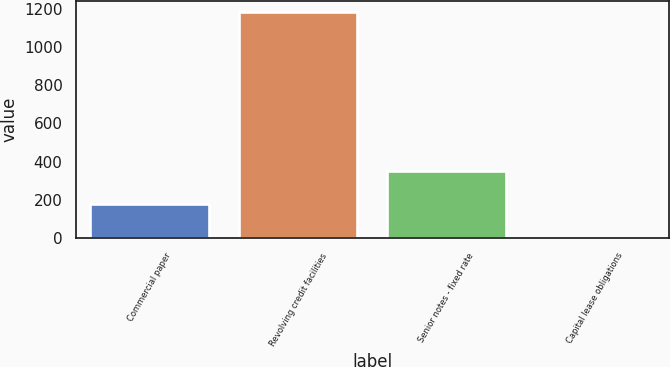<chart> <loc_0><loc_0><loc_500><loc_500><bar_chart><fcel>Commercial paper<fcel>Revolving credit facilities<fcel>Senior notes - fixed rate<fcel>Capital lease obligations<nl><fcel>179.5<fcel>1181.4<fcel>350<fcel>0.7<nl></chart> 